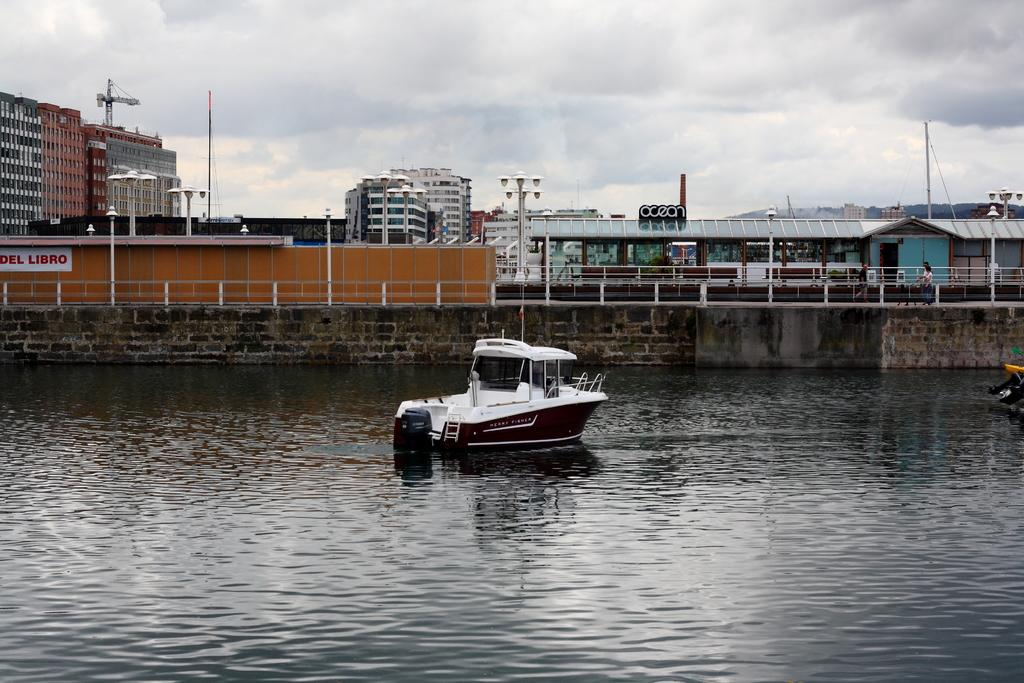<image>
Create a compact narrative representing the image presented. A boat on the water, behind it to the left is a sign that says Del Libro. 